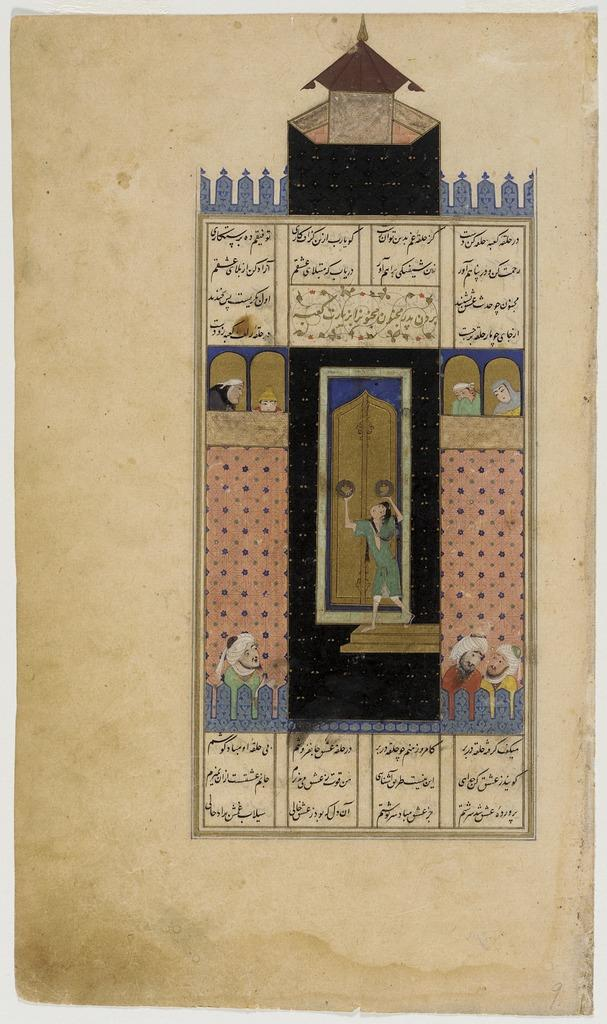What is the main subject of the painting in the image? There is a painting of a castle in the image. Can you describe any other elements in the image besides the painting? Yes, there are a few persons in the image. What type of amusement can be seen in the mine in the image? There is no mine or amusement present in the image; it features a painting of a castle and a few persons. 